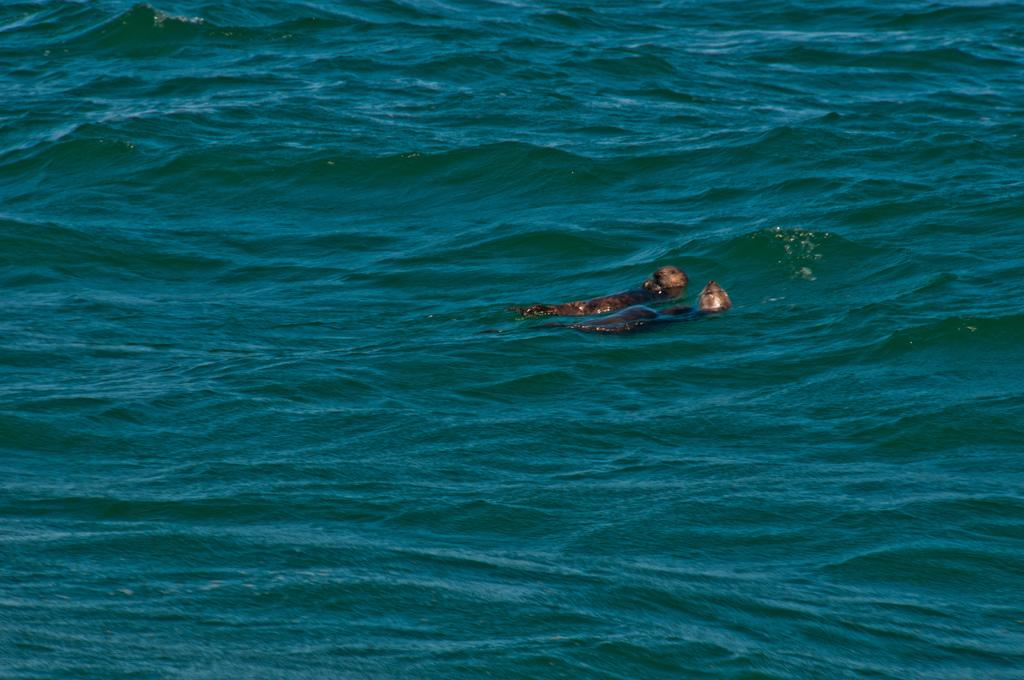What animals are present in the image? There are two seals in the image. Where are the seals located? The seals are in the water. What type of porter is serving drinks to the seals in the image? There is no porter present in the image, nor are any drinks being served to the seals. 